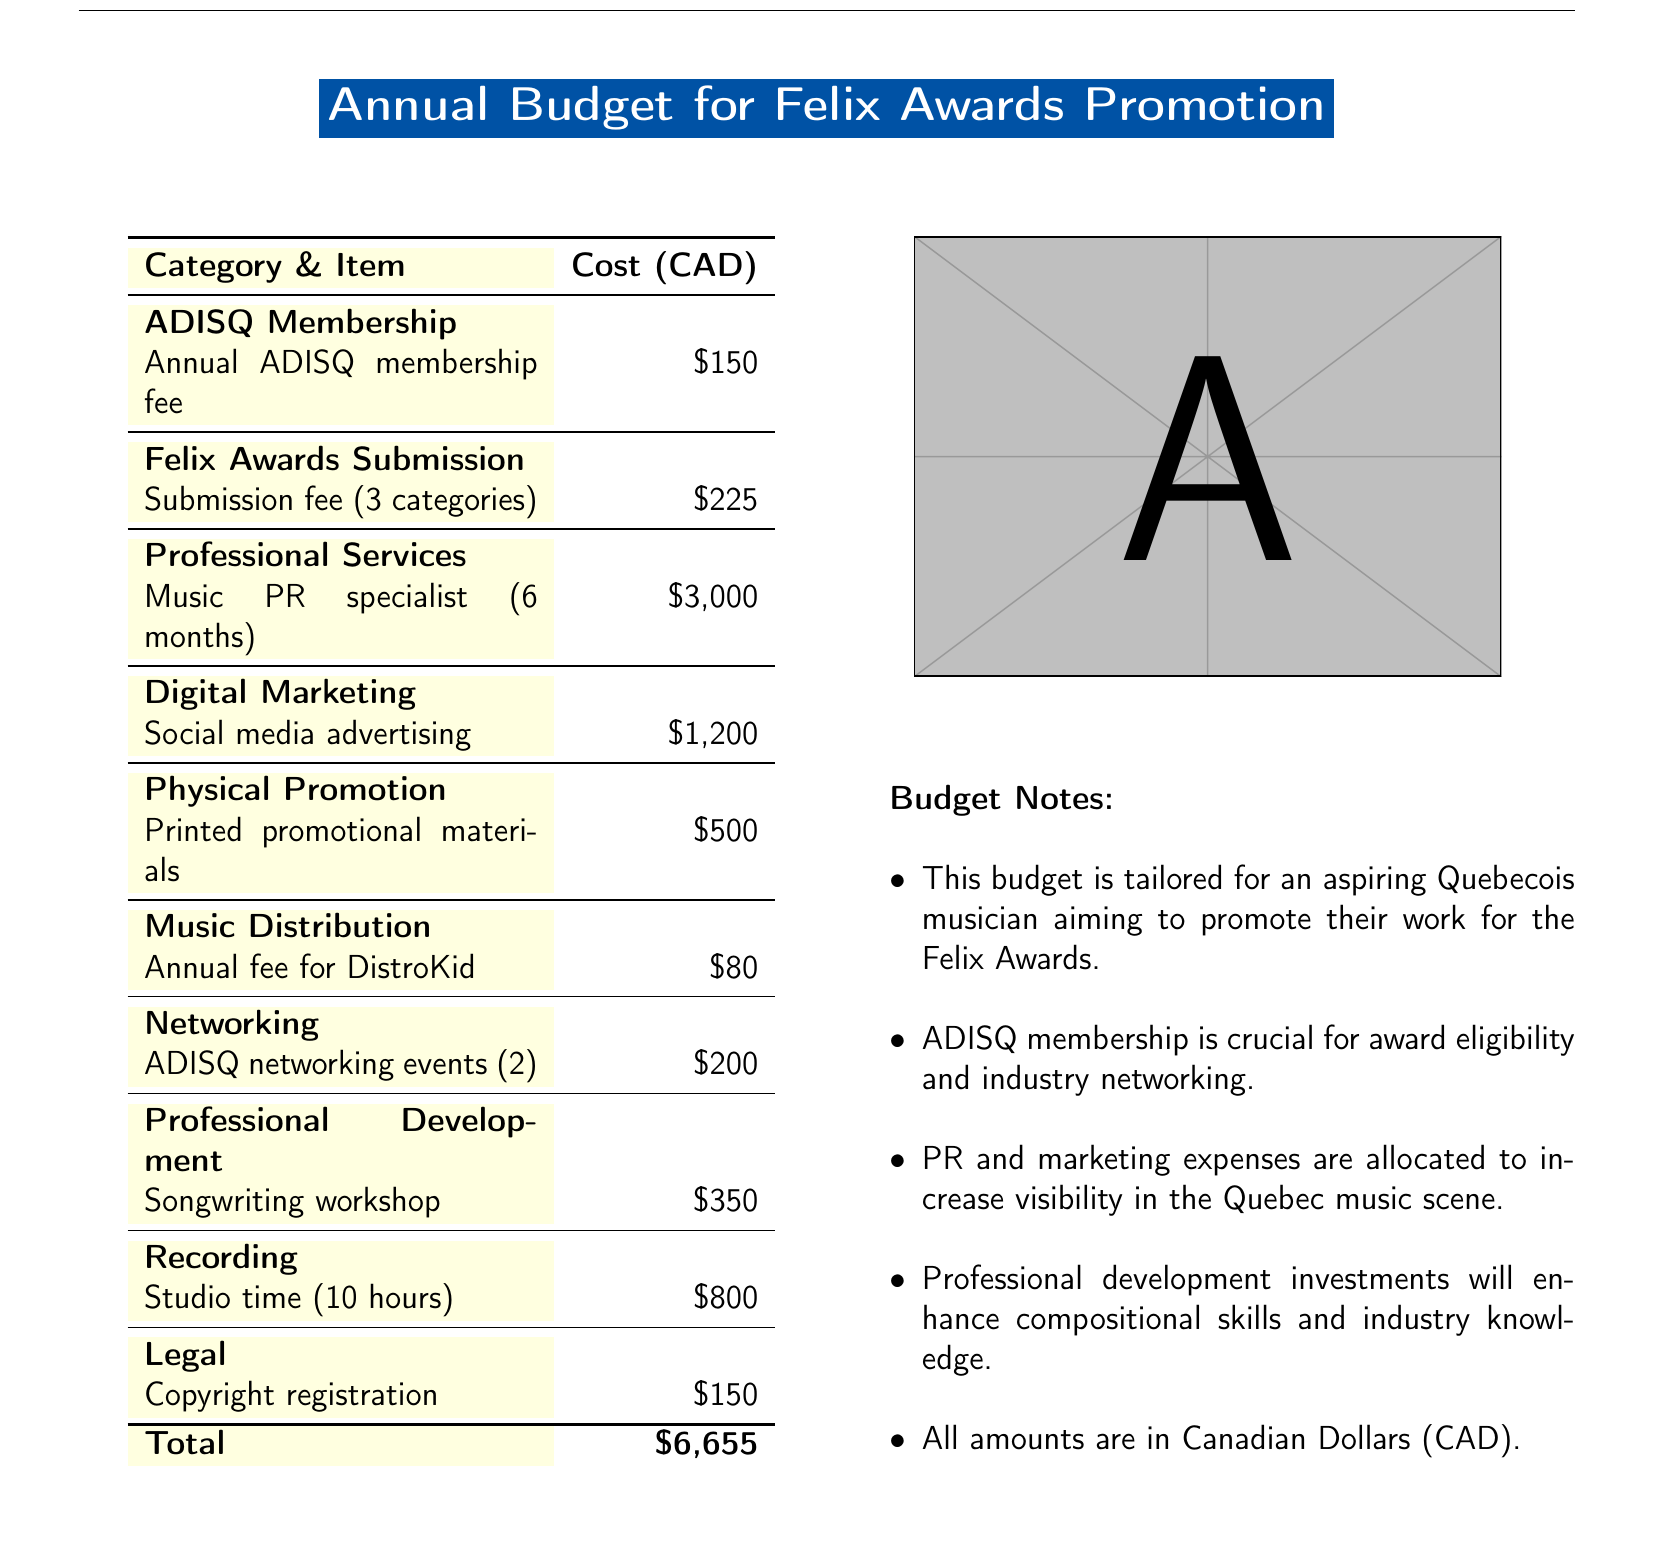What is the total budget for Felix Awards promotion? The total budget is listed at the bottom of the document, which sums all individual expenses.
Answer: $6,655 How much is the annual ADISQ membership fee? The document specifies the annual fee for ADISQ membership under the corresponding category.
Answer: $150 How many categories can be submitted for the Felix Awards? The submission fee section mentions that the fees cover submissions for three categories.
Answer: 3 categories What is the cost of studio time? The document clearly states the cost associated with studio time in the recording section.
Answer: $800 How much is allocated for social media advertising? The cost for digital marketing, specifically for social media advertising, is indicated in that category.
Answer: $1,200 What is the cost for a songwriting workshop? The document outlines the cost of professional development and includes the price for a songwriting workshop.
Answer: $350 How many ADISQ networking events are included in the budget? The networking category lists events and specifies how many events are budgeted for.
Answer: 2 What service can be hired for $3,000? The document mentions hiring a music PR specialist for a six-month duration under professional services.
Answer: Music PR specialist What is the cost for copyright registration? The legal section of the budget details the cost required for copyright registration.
Answer: $150 